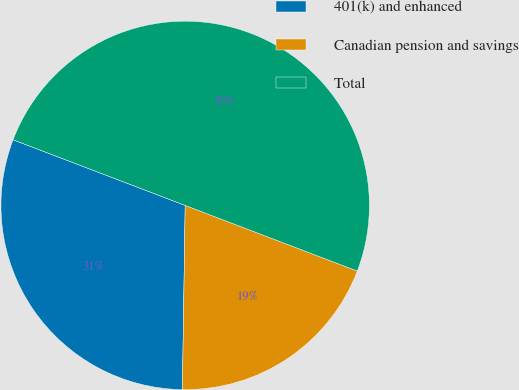Convert chart to OTSL. <chart><loc_0><loc_0><loc_500><loc_500><pie_chart><fcel>401(k) and enhanced<fcel>Canadian pension and savings<fcel>Total<nl><fcel>30.56%<fcel>19.44%<fcel>50.0%<nl></chart> 